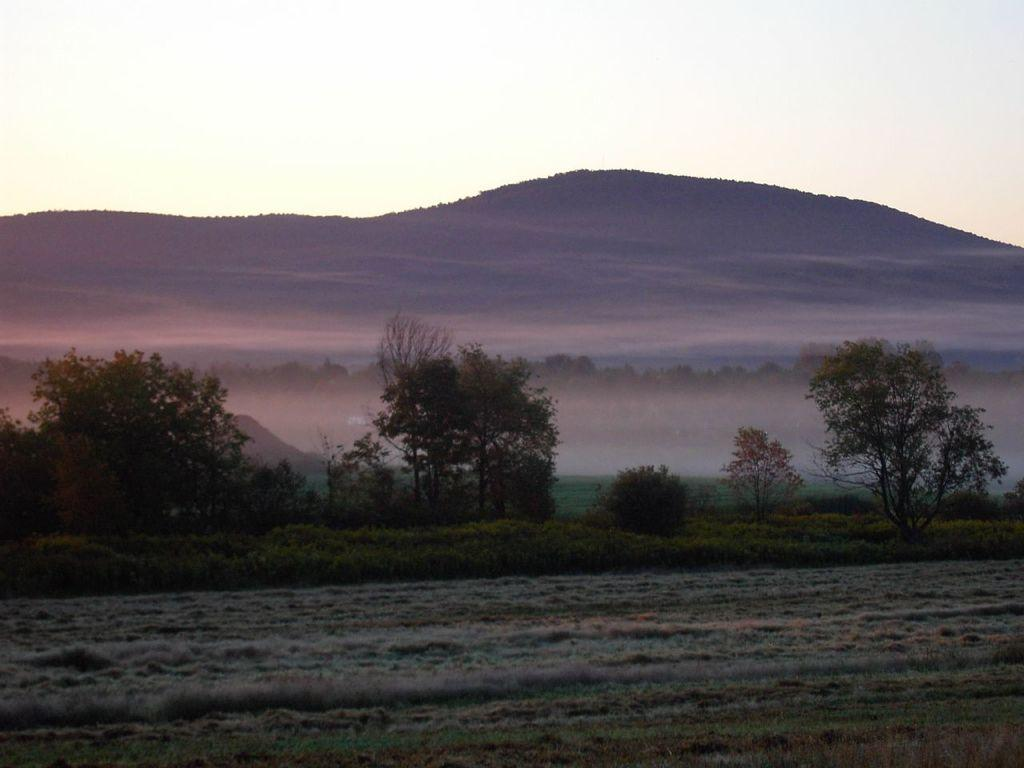What type of landscape is at the bottom of the image? There is cultivated land at the bottom of the image. What can be seen behind the cultivated land? There are small plants and trees behind the cultivated land. What geographical features are visible in the background of the image? There are hills visible in the background of the image. What is visible at the top of the image? The sky is visible at the top of the image. What type of brick is used to build the mark on the hill in the image? There is no brick or mark on the hill in the image; it only features cultivated land, small plants and trees, hills, and the sky. 